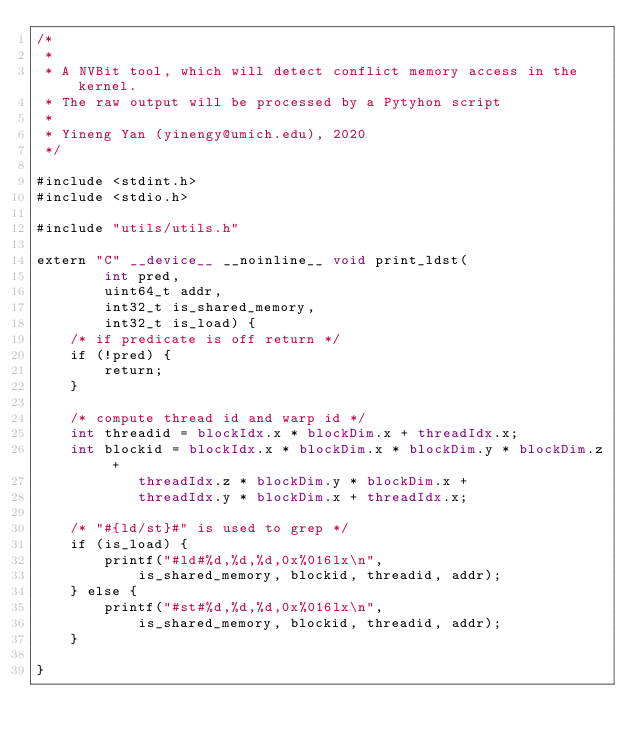Convert code to text. <code><loc_0><loc_0><loc_500><loc_500><_Cuda_>/* 
 *
 * A NVBit tool, which will detect conflict memory access in the kernel.
 * The raw output will be processed by a Pytyhon script
 *
 * Yineng Yan (yinengy@umich.edu), 2020
 */

#include <stdint.h>
#include <stdio.h>

#include "utils/utils.h"

extern "C" __device__ __noinline__ void print_ldst(
        int pred,
        uint64_t addr,
        int32_t is_shared_memory,
        int32_t is_load) {
    /* if predicate is off return */
    if (!pred) {
        return;
    }

    /* compute thread id and warp id */
    int threadid = blockIdx.x * blockDim.x + threadIdx.x;
    int blockid = blockIdx.x * blockDim.x * blockDim.y * blockDim.z + 
            threadIdx.z * blockDim.y * blockDim.x + 
            threadIdx.y * blockDim.x + threadIdx.x;

    /* "#{ld/st}#" is used to grep */
    if (is_load) {
        printf("#ld#%d,%d,%d,0x%016lx\n",
            is_shared_memory, blockid, threadid, addr);
    } else {
        printf("#st#%d,%d,%d,0x%016lx\n",
            is_shared_memory, blockid, threadid, addr);
    }

}</code> 